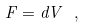<formula> <loc_0><loc_0><loc_500><loc_500>F = d V \ ,</formula> 